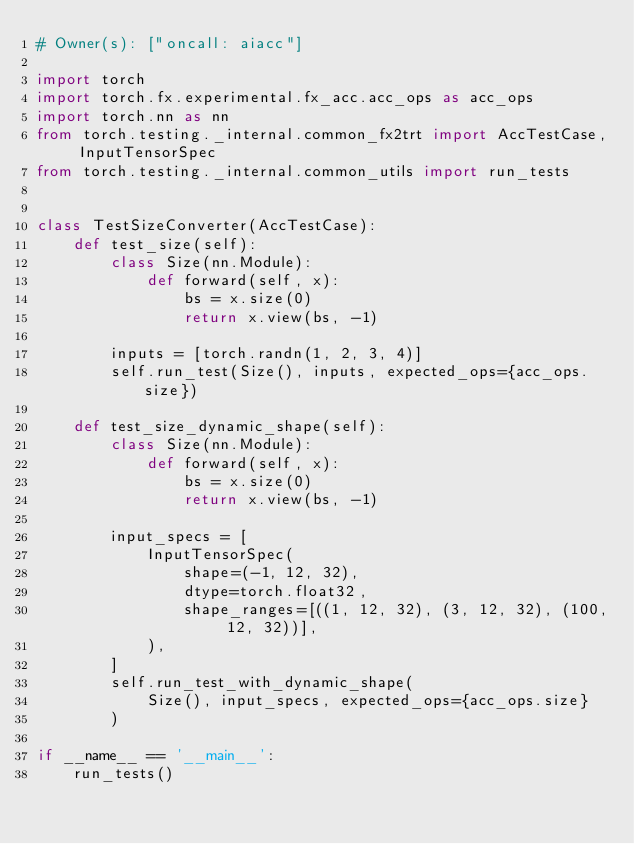<code> <loc_0><loc_0><loc_500><loc_500><_Python_># Owner(s): ["oncall: aiacc"]

import torch
import torch.fx.experimental.fx_acc.acc_ops as acc_ops
import torch.nn as nn
from torch.testing._internal.common_fx2trt import AccTestCase, InputTensorSpec
from torch.testing._internal.common_utils import run_tests


class TestSizeConverter(AccTestCase):
    def test_size(self):
        class Size(nn.Module):
            def forward(self, x):
                bs = x.size(0)
                return x.view(bs, -1)

        inputs = [torch.randn(1, 2, 3, 4)]
        self.run_test(Size(), inputs, expected_ops={acc_ops.size})

    def test_size_dynamic_shape(self):
        class Size(nn.Module):
            def forward(self, x):
                bs = x.size(0)
                return x.view(bs, -1)

        input_specs = [
            InputTensorSpec(
                shape=(-1, 12, 32),
                dtype=torch.float32,
                shape_ranges=[((1, 12, 32), (3, 12, 32), (100, 12, 32))],
            ),
        ]
        self.run_test_with_dynamic_shape(
            Size(), input_specs, expected_ops={acc_ops.size}
        )

if __name__ == '__main__':
    run_tests()
</code> 